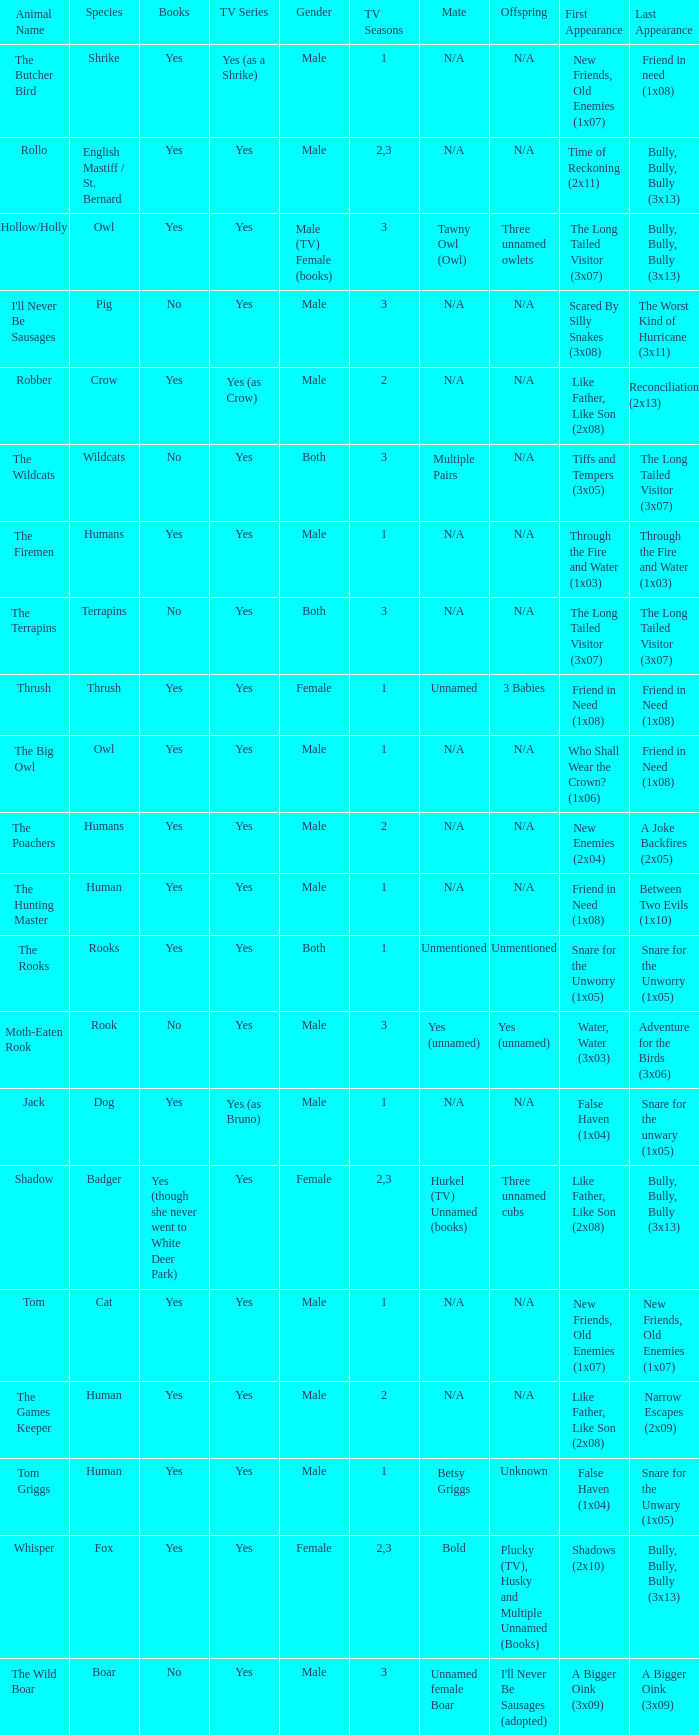What is the mate for Last Appearance of bully, bully, bully (3x13) for the animal named hollow/holly later than season 1? Tawny Owl (Owl). 